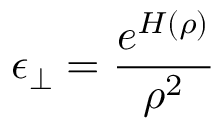<formula> <loc_0><loc_0><loc_500><loc_500>\epsilon _ { \perp } = \frac { e ^ { H ( \rho ) } } { \rho ^ { 2 } }</formula> 